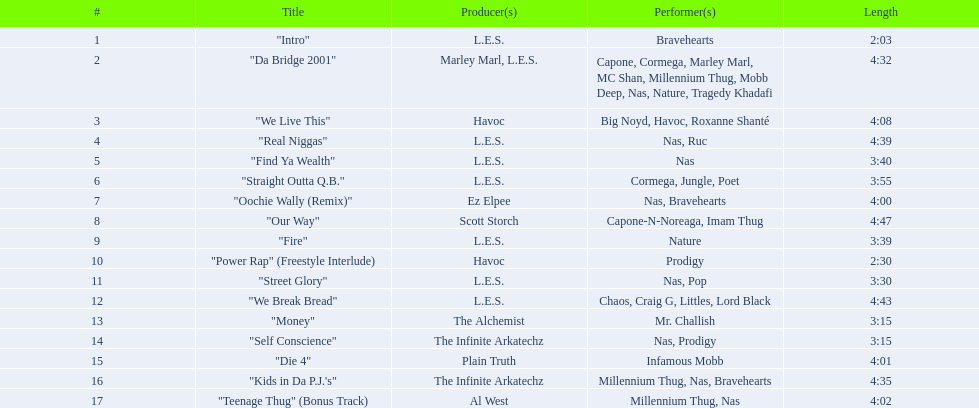What are the track lengths on the nas & ill will records presents qb's finest album? 2:03, 4:32, 4:08, 4:39, 3:40, 3:55, 4:00, 4:47, 3:39, 2:30, 3:30, 4:43, 3:15, 3:15, 4:01, 4:35, 4:02. Out of those, which is the longest? 4:47. 